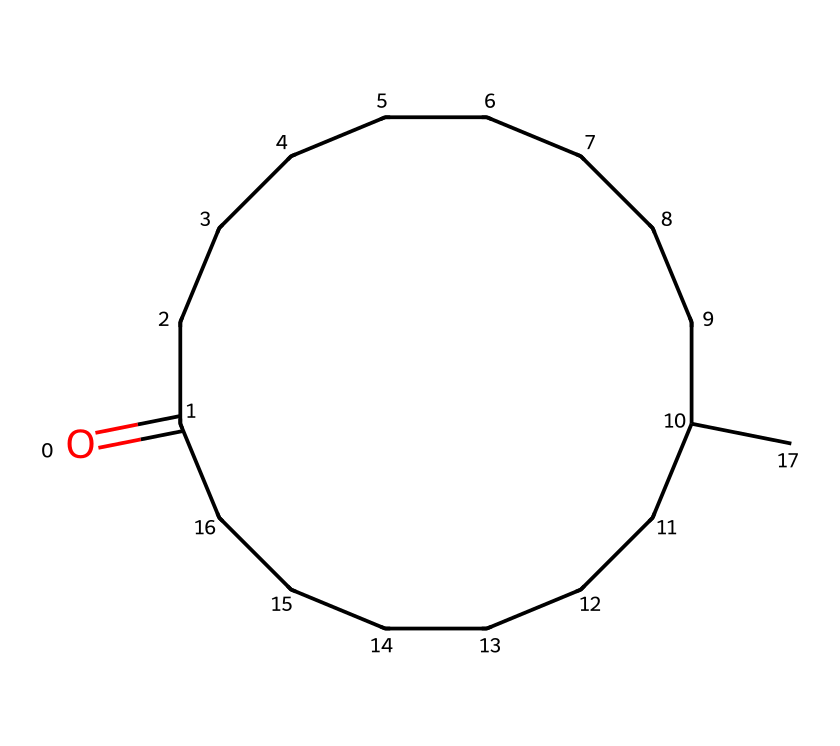What is the functional group present in muscone? The structure shows a carbonyl group (C=O) present within a long carbon chain, indicating that this molecule is a ketone.
Answer: ketone How many carbon atoms are in muscone? By counting each carbon in the structure, there are a total of 18 carbon atoms in the molecule.
Answer: 18 What type of interaction allows muscone to be a long-lasting scent in perfumes? The long hydrocarbon chain and the carbonyl group facilitate intermolecular forces like van der Waals interactions, which help to retain the fragrance for a longer period.
Answer: van der Waals interactions What is the molecular formula of muscone? From the structure, one can deduce that the molecular formula is C18H34O, representing 18 carbon atoms, 34 hydrogen atoms, and 1 oxygen atom.
Answer: C18H34O What type of compound is muscone primarily used in? Given its properties and structure, muscone is primarily used in the formulation of perfumes.
Answer: perfumes How many cyclic structures are present in muscone? The structural formula of muscone contains one cyclic structure, as indicated by the ring formed by carbon atoms.
Answer: 1 